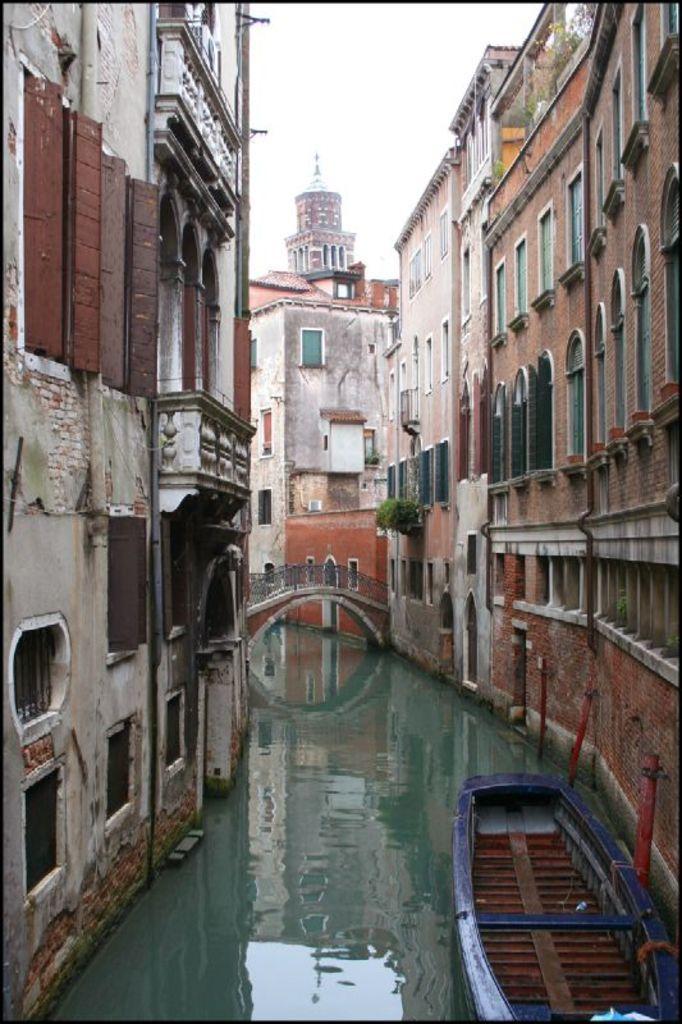In one or two sentences, can you explain what this image depicts? In this image, there are a few buildings. We can also see some water. We can see a boat and a bridge. We can also see the sky. 